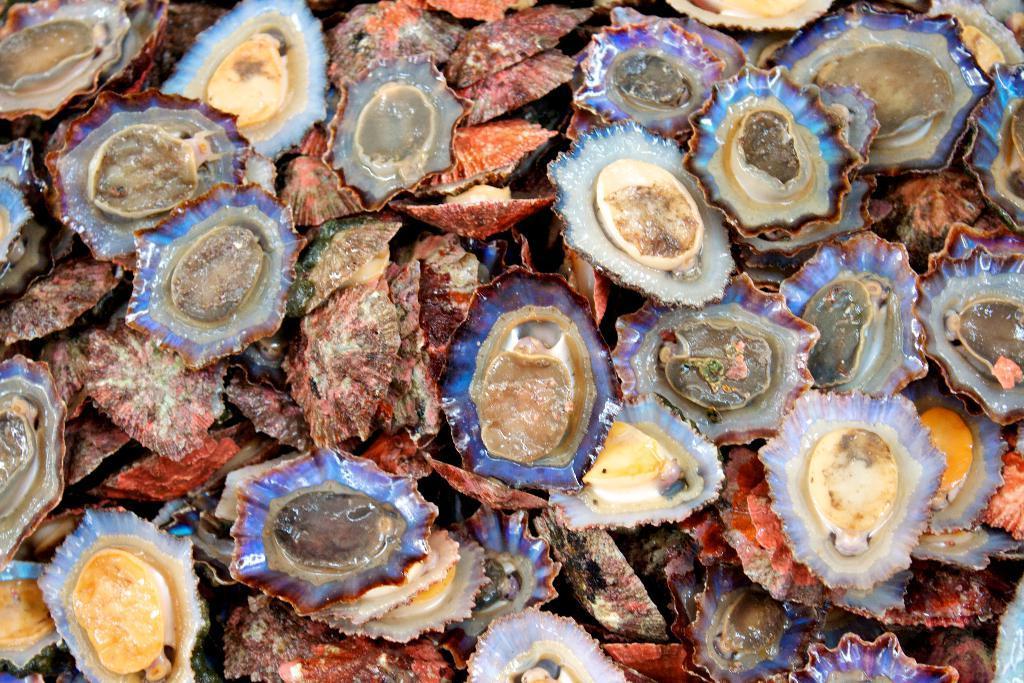Describe this image in one or two sentences. In this picture we can see many shells with scallops in it. 